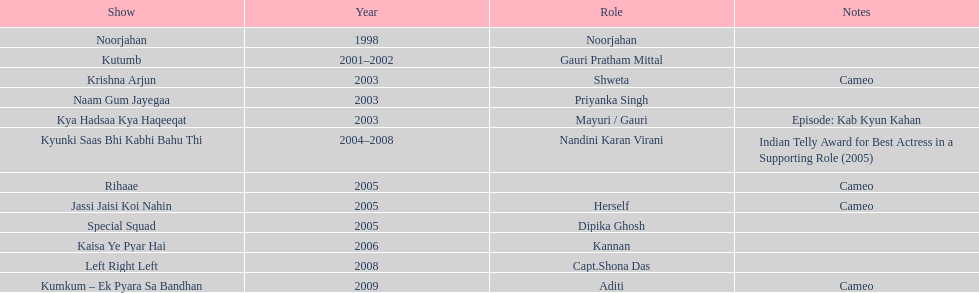How many total television shows has gauri starred in? 12. 